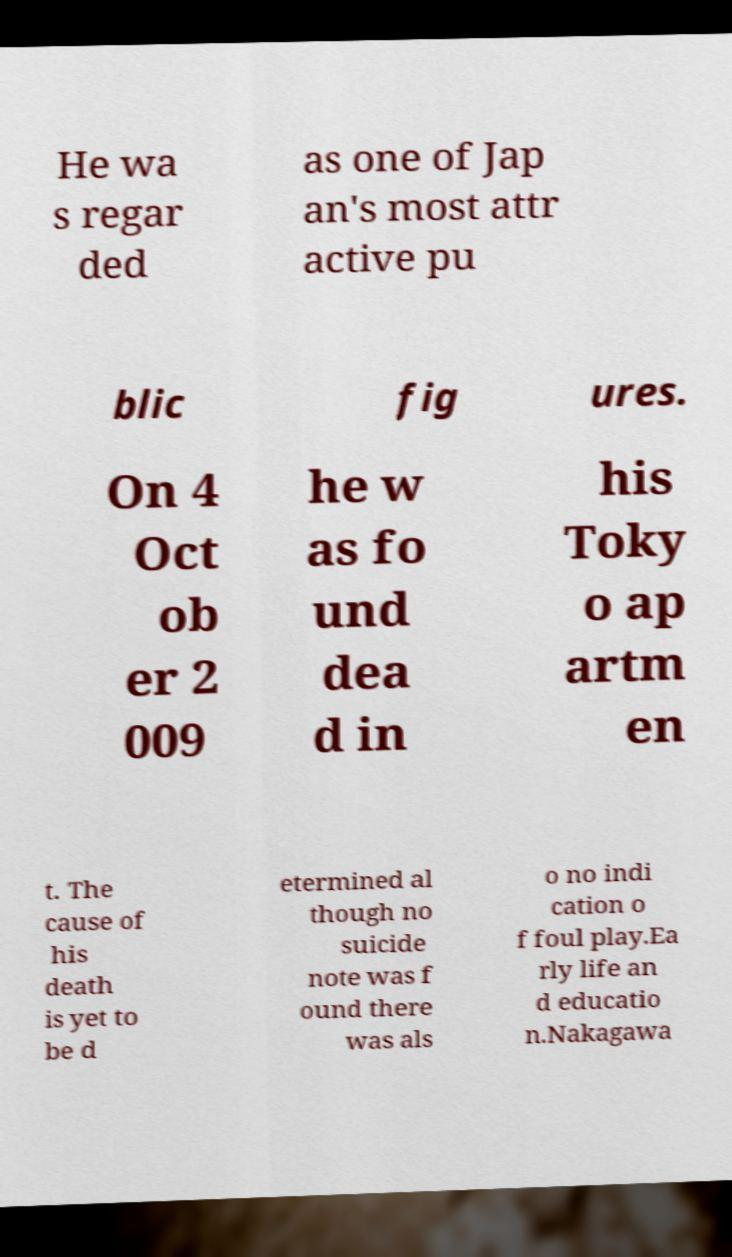For documentation purposes, I need the text within this image transcribed. Could you provide that? He wa s regar ded as one of Jap an's most attr active pu blic fig ures. On 4 Oct ob er 2 009 he w as fo und dea d in his Toky o ap artm en t. The cause of his death is yet to be d etermined al though no suicide note was f ound there was als o no indi cation o f foul play.Ea rly life an d educatio n.Nakagawa 